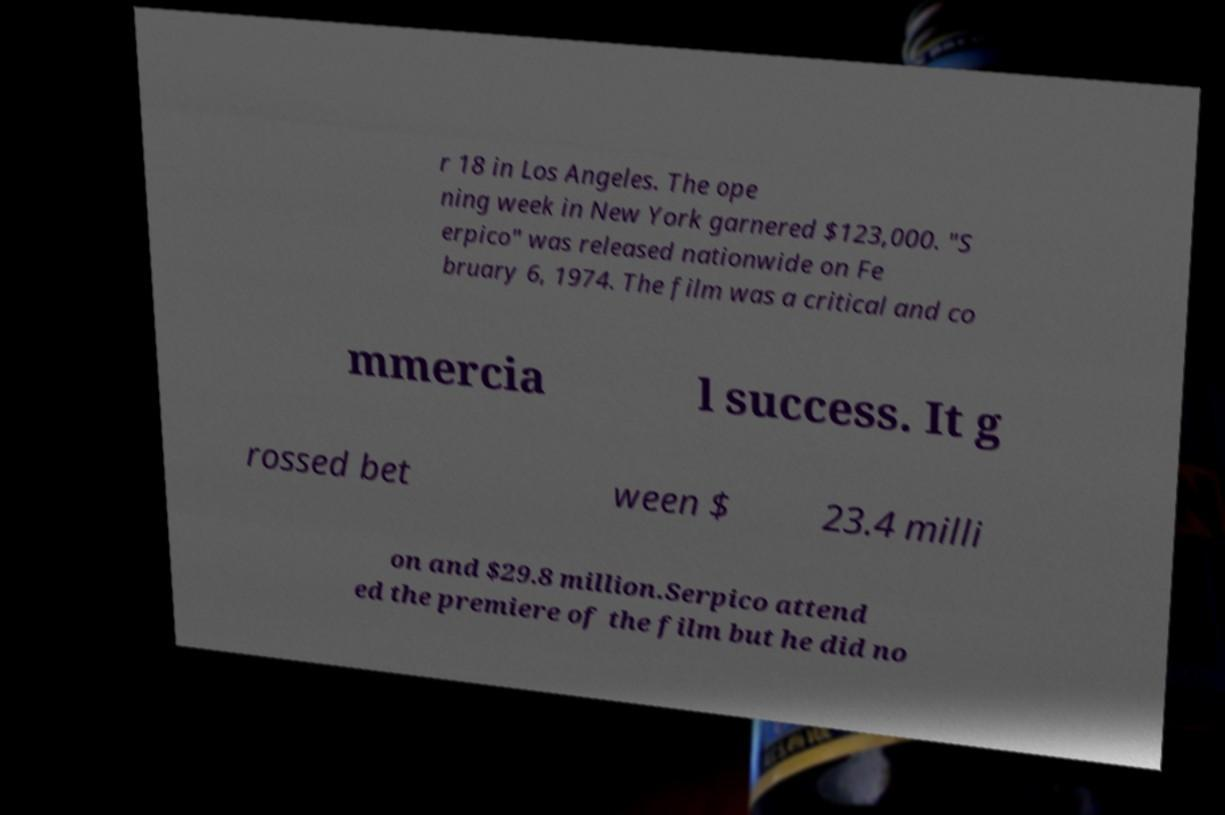Could you extract and type out the text from this image? r 18 in Los Angeles. The ope ning week in New York garnered $123,000. "S erpico" was released nationwide on Fe bruary 6, 1974. The film was a critical and co mmercia l success. It g rossed bet ween $ 23.4 milli on and $29.8 million.Serpico attend ed the premiere of the film but he did no 